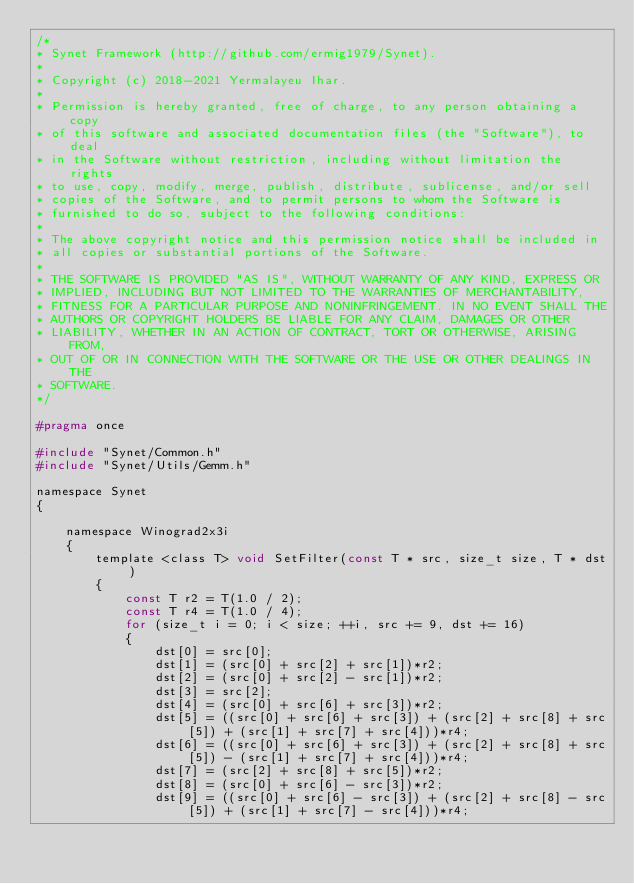Convert code to text. <code><loc_0><loc_0><loc_500><loc_500><_C_>/*
* Synet Framework (http://github.com/ermig1979/Synet).
*
* Copyright (c) 2018-2021 Yermalayeu Ihar.
*
* Permission is hereby granted, free of charge, to any person obtaining a copy
* of this software and associated documentation files (the "Software"), to deal
* in the Software without restriction, including without limitation the rights
* to use, copy, modify, merge, publish, distribute, sublicense, and/or sell
* copies of the Software, and to permit persons to whom the Software is
* furnished to do so, subject to the following conditions:
*
* The above copyright notice and this permission notice shall be included in
* all copies or substantial portions of the Software.
*
* THE SOFTWARE IS PROVIDED "AS IS", WITHOUT WARRANTY OF ANY KIND, EXPRESS OR
* IMPLIED, INCLUDING BUT NOT LIMITED TO THE WARRANTIES OF MERCHANTABILITY,
* FITNESS FOR A PARTICULAR PURPOSE AND NONINFRINGEMENT. IN NO EVENT SHALL THE
* AUTHORS OR COPYRIGHT HOLDERS BE LIABLE FOR ANY CLAIM, DAMAGES OR OTHER
* LIABILITY, WHETHER IN AN ACTION OF CONTRACT, TORT OR OTHERWISE, ARISING FROM,
* OUT OF OR IN CONNECTION WITH THE SOFTWARE OR THE USE OR OTHER DEALINGS IN THE
* SOFTWARE.
*/

#pragma once

#include "Synet/Common.h"
#include "Synet/Utils/Gemm.h"

namespace Synet
{

    namespace Winograd2x3i
    {
        template <class T> void SetFilter(const T * src, size_t size, T * dst)
        {
            const T r2 = T(1.0 / 2);
            const T r4 = T(1.0 / 4);
            for (size_t i = 0; i < size; ++i, src += 9, dst += 16)
            {
                dst[0] = src[0];
                dst[1] = (src[0] + src[2] + src[1])*r2;
                dst[2] = (src[0] + src[2] - src[1])*r2;
                dst[3] = src[2];
                dst[4] = (src[0] + src[6] + src[3])*r2;
                dst[5] = ((src[0] + src[6] + src[3]) + (src[2] + src[8] + src[5]) + (src[1] + src[7] + src[4]))*r4;
                dst[6] = ((src[0] + src[6] + src[3]) + (src[2] + src[8] + src[5]) - (src[1] + src[7] + src[4]))*r4;
                dst[7] = (src[2] + src[8] + src[5])*r2;
                dst[8] = (src[0] + src[6] - src[3])*r2;
                dst[9] = ((src[0] + src[6] - src[3]) + (src[2] + src[8] - src[5]) + (src[1] + src[7] - src[4]))*r4;</code> 